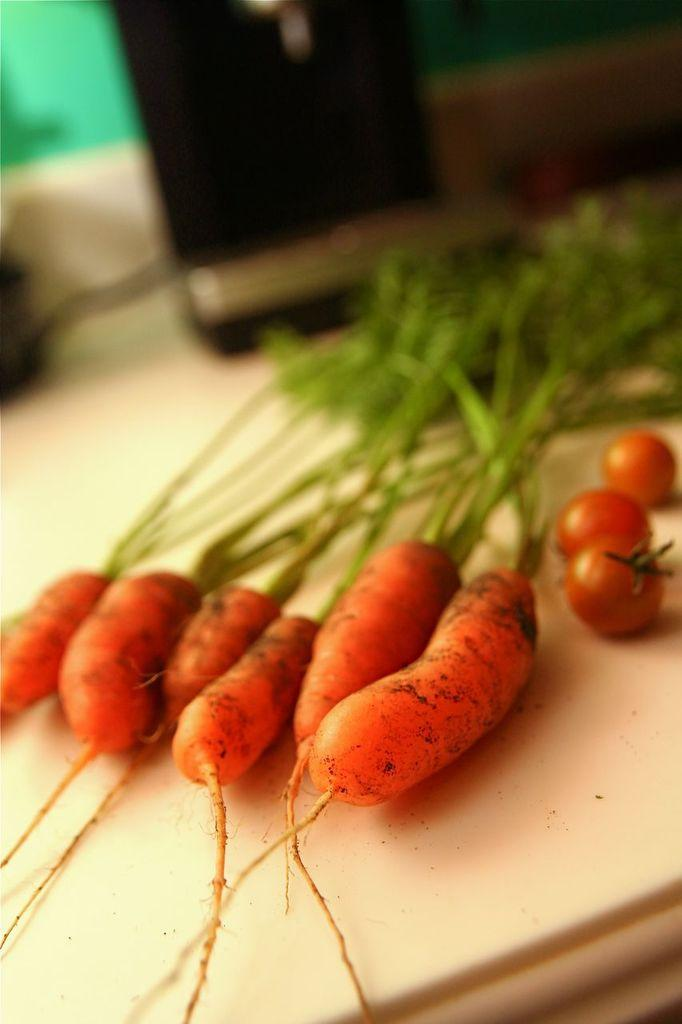How many carrots with leaves are visible in the image? There are six carrots with leaves in the front of the image. What other vegetables can be seen in the image? Tomatoes are visible on the right side of the image. Can you describe the background of the image? The background of the image is blurry. What type of alarm is being offered by the carrots in the image? There is no alarm present in the image; it features carrots and tomatoes. What color are the trousers worn by the tomatoes in the image? There are no trousers or tomatoes wearing trousers in the image. 